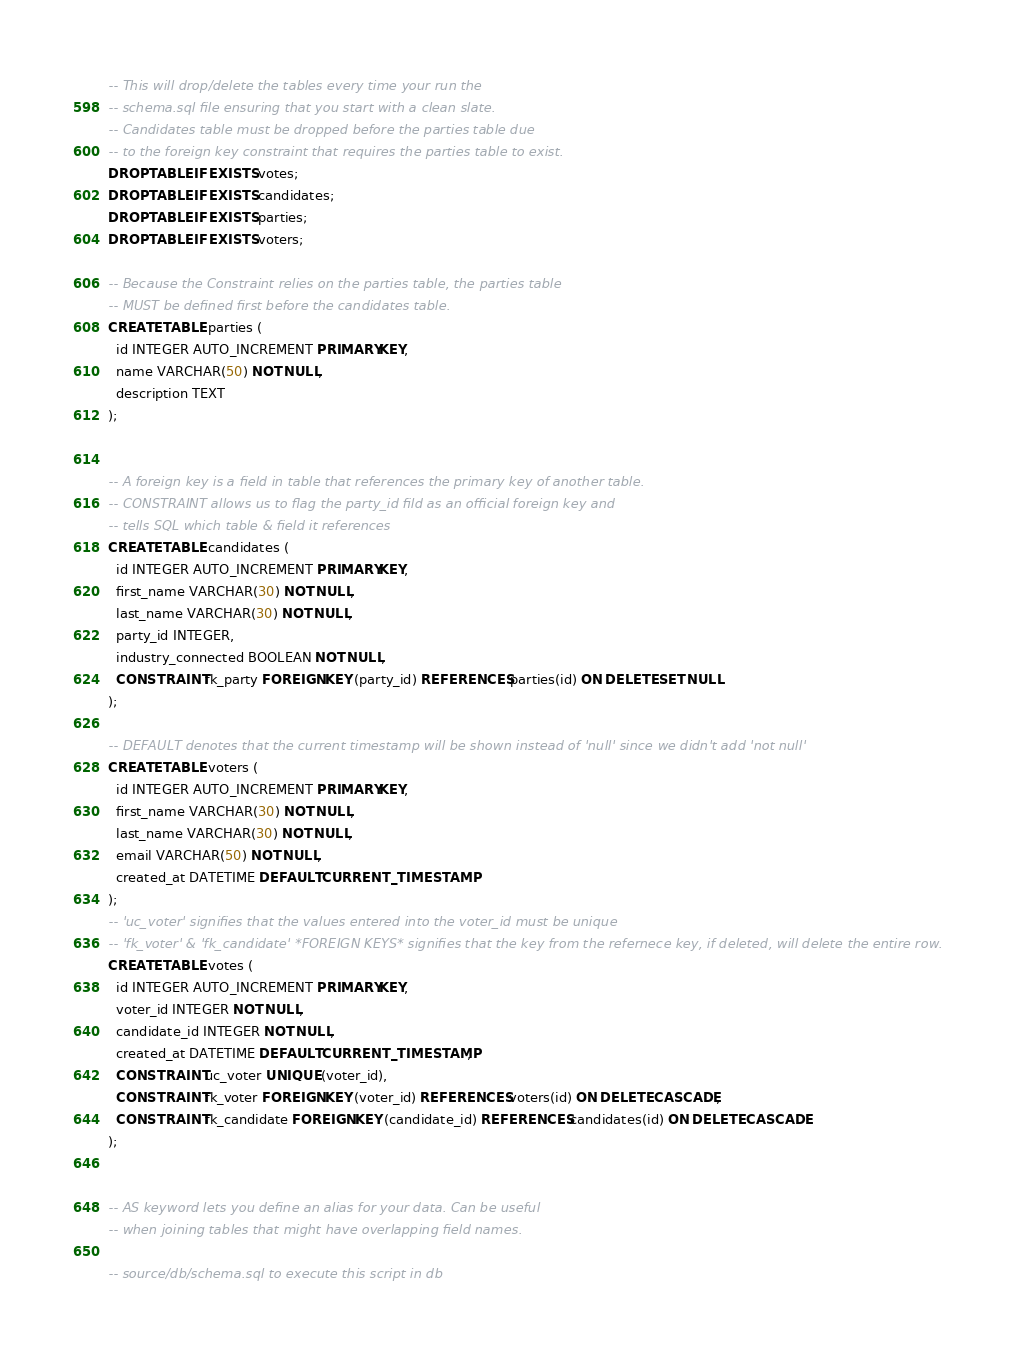Convert code to text. <code><loc_0><loc_0><loc_500><loc_500><_SQL_>-- This will drop/delete the tables every time your run the 
-- schema.sql file ensuring that you start with a clean slate.
-- Candidates table must be dropped before the parties table due 
-- to the foreign key constraint that requires the parties table to exist.
DROP TABLE IF EXISTS votes;
DROP TABLE IF EXISTS candidates;  
DROP TABLE IF EXISTS parties;
DROP TABLE IF EXISTS voters;

-- Because the Constraint relies on the parties table, the parties table
-- MUST be defined first before the candidates table.
CREATE TABLE parties (
  id INTEGER AUTO_INCREMENT PRIMARY KEY,
  name VARCHAR(50) NOT NULL,
  description TEXT
);


-- A foreign key is a field in table that references the primary key of another table.
-- CONSTRAINT allows us to flag the party_id fild as an official foreign key and 
-- tells SQL which table & field it references
CREATE TABLE candidates (
  id INTEGER AUTO_INCREMENT PRIMARY KEY,
  first_name VARCHAR(30) NOT NULL,
  last_name VARCHAR(30) NOT NULL,
  party_id INTEGER,
  industry_connected BOOLEAN NOT NULL,
  CONSTRAINT fk_party FOREIGN KEY (party_id) REFERENCES parties(id) ON DELETE SET NULL
);

-- DEFAULT denotes that the current timestamp will be shown instead of 'null' since we didn't add 'not null'
CREATE TABLE voters (
  id INTEGER AUTO_INCREMENT PRIMARY KEY,
  first_name VARCHAR(30) NOT NULL,
  last_name VARCHAR(30) NOT NULL,
  email VARCHAR(50) NOT NULL,
  created_at DATETIME DEFAULT CURRENT_TIMESTAMP
);
-- 'uc_voter' signifies that the values entered into the voter_id must be unique
-- 'fk_voter' & 'fk_candidate' *FOREIGN KEYS* signifies that the key from the refernece key, if deleted, will delete the entire row.
CREATE TABLE votes (
  id INTEGER AUTO_INCREMENT PRIMARY KEY,
  voter_id INTEGER NOT NULL,
  candidate_id INTEGER NOT NULL,
  created_at DATETIME DEFAULT CURRENT_TIMESTAMP,
  CONSTRAINT uc_voter UNIQUE (voter_id),
  CONSTRAINT fk_voter FOREIGN KEY (voter_id) REFERENCES voters(id) ON DELETE CASCADE,
  CONSTRAINT fk_candidate FOREIGN KEY (candidate_id) REFERENCES candidates(id) ON DELETE CASCADE
);


-- AS keyword lets you define an alias for your data. Can be useful
-- when joining tables that might have overlapping field names.

-- source/db/schema.sql to execute this script in db</code> 